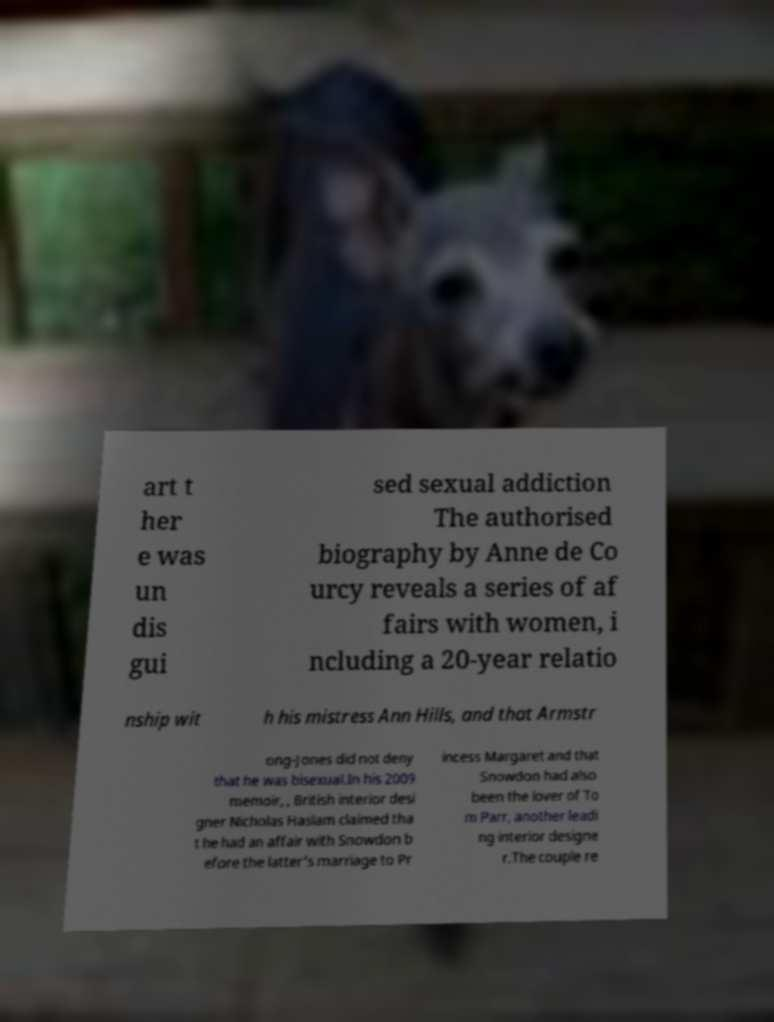For documentation purposes, I need the text within this image transcribed. Could you provide that? art t her e was un dis gui sed sexual addiction The authorised biography by Anne de Co urcy reveals a series of af fairs with women, i ncluding a 20-year relatio nship wit h his mistress Ann Hills, and that Armstr ong-Jones did not deny that he was bisexual.In his 2009 memoir, , British interior desi gner Nicholas Haslam claimed tha t he had an affair with Snowdon b efore the latter's marriage to Pr incess Margaret and that Snowdon had also been the lover of To m Parr, another leadi ng interior designe r.The couple re 